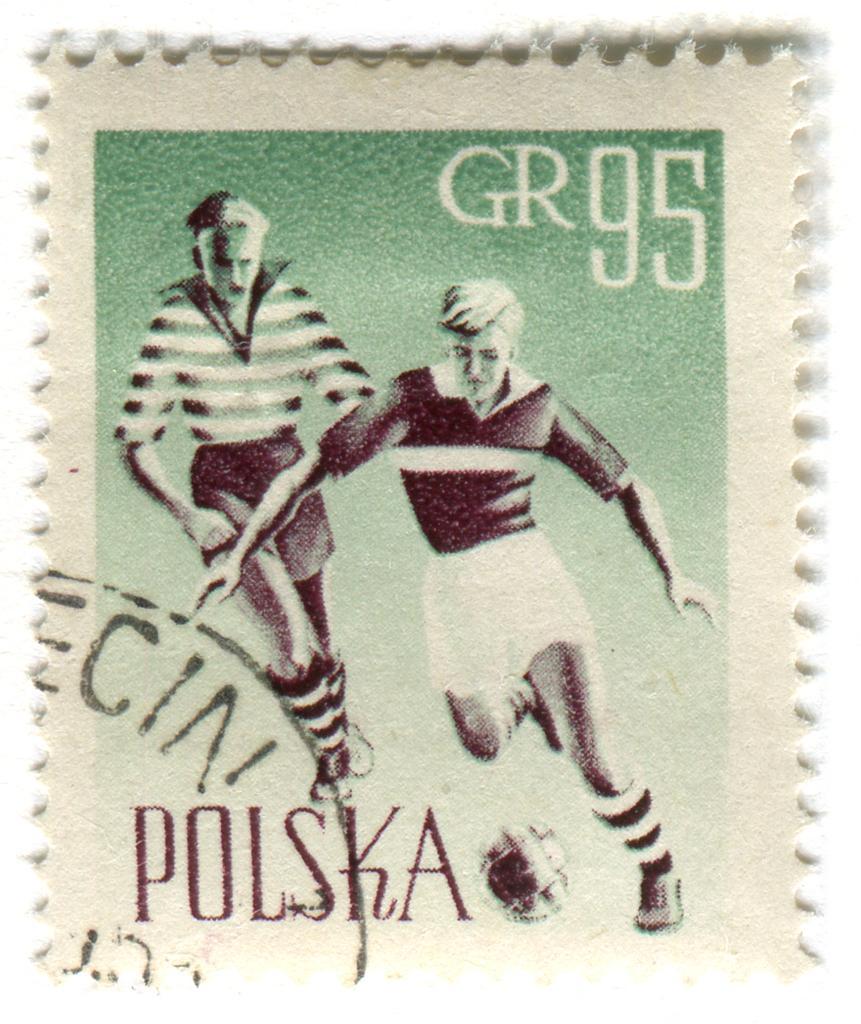How would you summarize this image in a sentence or two? In this image there is a paper with images of two people and some text on it. 